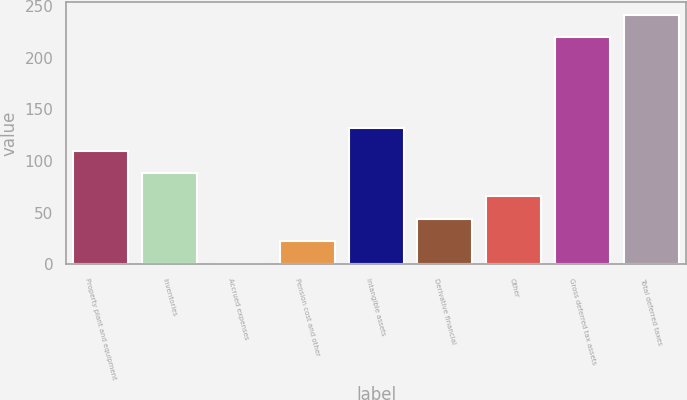Convert chart to OTSL. <chart><loc_0><loc_0><loc_500><loc_500><bar_chart><fcel>Property plant and equipment<fcel>Inventories<fcel>Accrued expenses<fcel>Pension cost and other<fcel>Intangible assets<fcel>Derivative financial<fcel>Other<fcel>Gross deferred tax assets<fcel>Total deferred taxes<nl><fcel>110<fcel>88.02<fcel>0.1<fcel>22.08<fcel>131.98<fcel>44.06<fcel>66.04<fcel>219.9<fcel>241.88<nl></chart> 